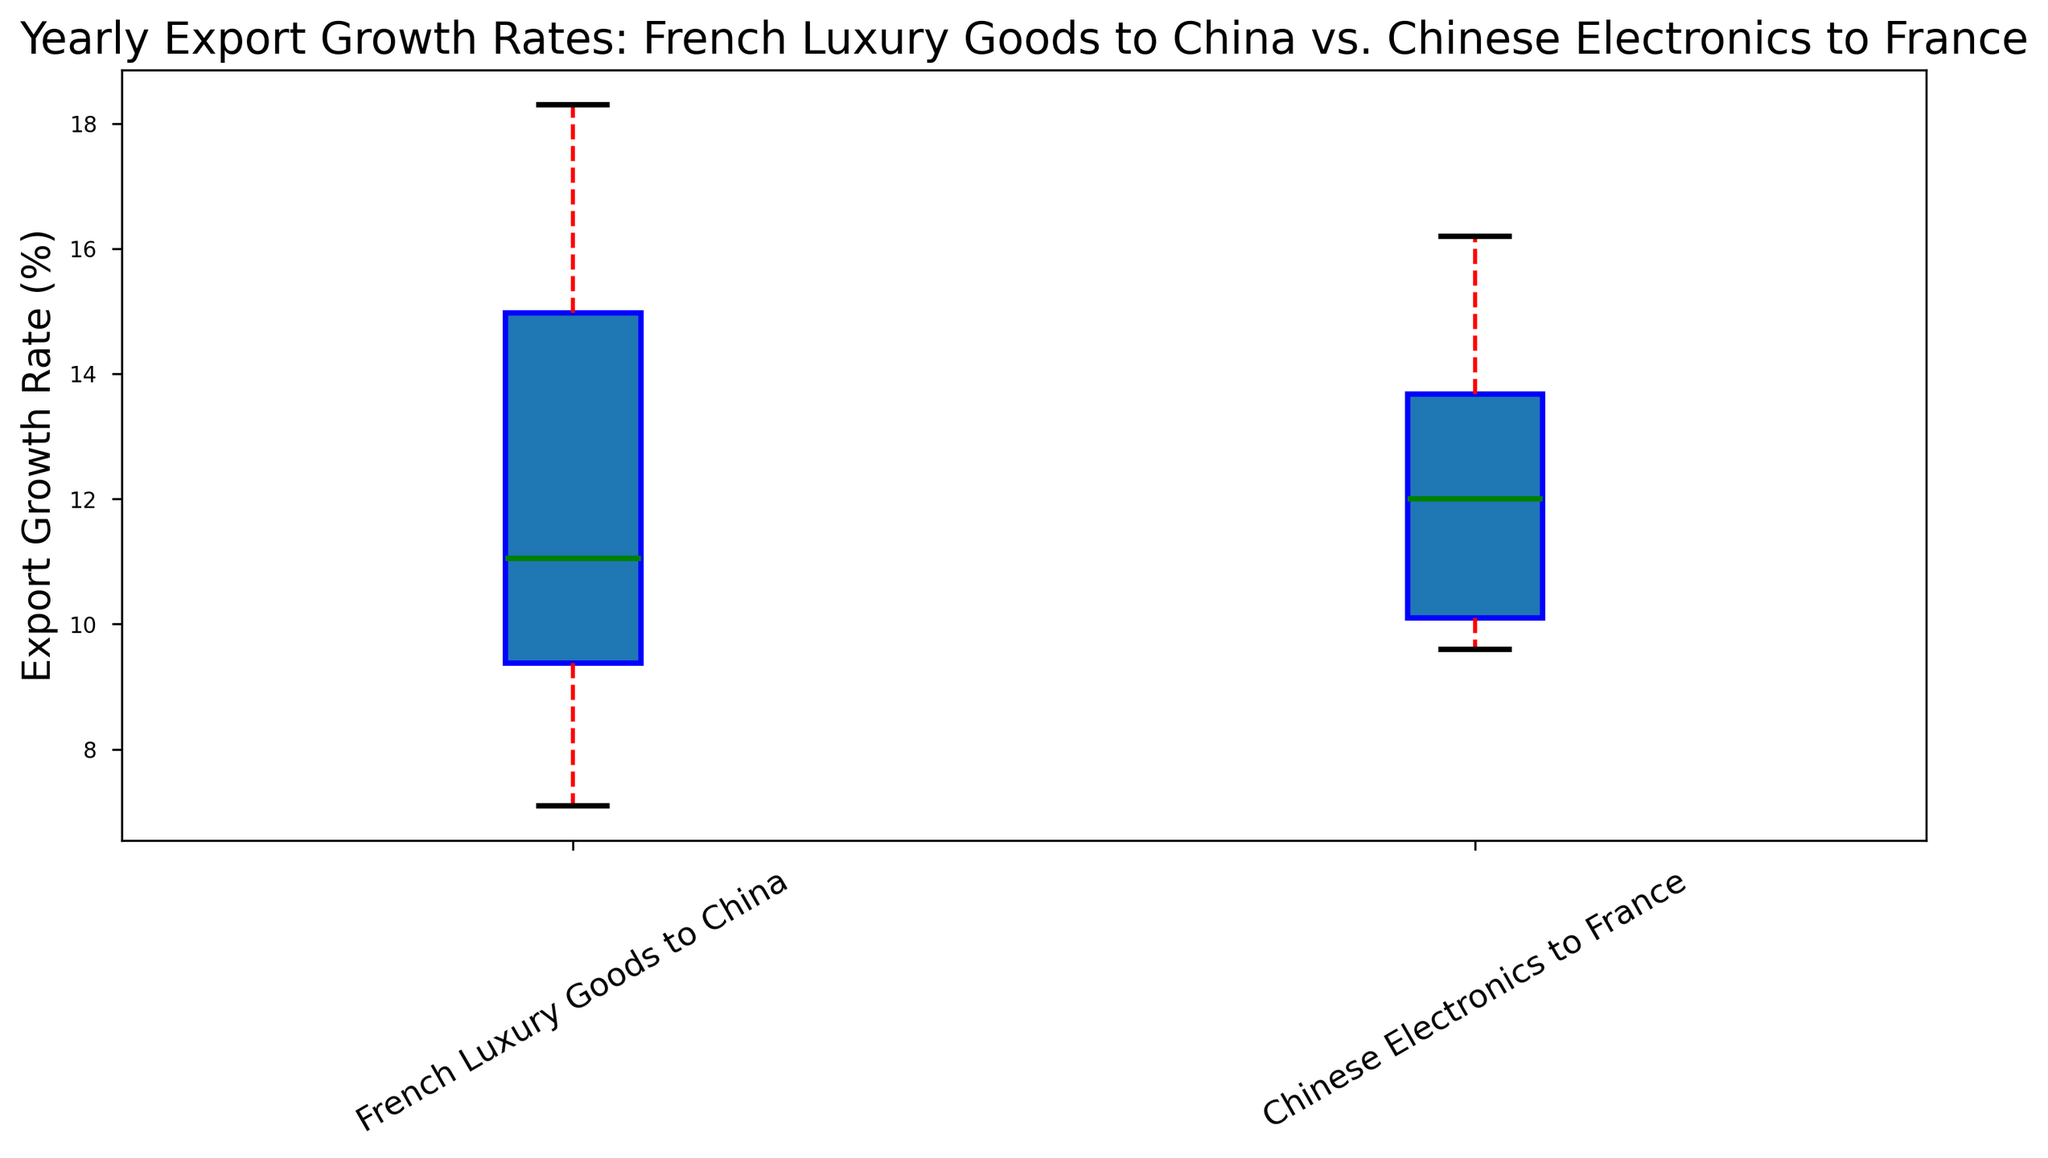What's the median export growth rate for French Luxury Goods to China? To find the median, we need to order the growth rates for French Luxury Goods to China and select the middle value. The rates are: [7.1, 8.4, 9.7, 10.9, 11.2, 14.8, 15.5, 18.3]. There are 8 values, so the median is the average of the 4th and 5th values: (10.9 + 11.2) / 2 = 11.05.
Answer: 11.05 Which category has a higher median export growth rate? We compare the median values of both categories. The median for French Luxury Goods to China is 11.05%, and for Chinese Electronics to France, the median is between the 4th and 5th values of [9.6, 9.8, 10.2, 11.7, 12.3, 13.4, 14.5, 16.2], which is (11.7 + 12.3) / 2 = 12.0%. Thus, Chinese Electronics to France has a higher median.
Answer: Chinese Electronics to France Which category exhibits a higher level of variation in export growth rates? The variation can be observed by looking at the spread of the box plot. A higher level of variation is indicated by a wider interquartile range (IQR) and longer whiskers. Observing the box plots, the French Luxury Goods to China category appears to be more spread out compared to Chinese Electronics to France.
Answer: French Luxury Goods to China What is the interquartile range (IQR) for Chinese Electronics to France? The IQR is the difference between the third quartile (Q3) and the first quartile (Q1). For Chinese Electronics to France, these values can be estimated from the box plot. Let's say Q1 ≈ 9.85 and Q3 ≈ 14.1. Therefore, IQR = 14.1 - 9.85 = 4.25.
Answer: 4.25 Are there any outliers in the export growth rates for French Luxury Goods to China? Outliers are typically shown as individual points outside the whiskers on a box plot. Observing the plot, no individual points are displayed outside the whiskers for French Luxury Goods to China, hence there are no outliers.
Answer: No By how much did the maximum export growth rate differ between the two categories? The maximum (upper whisker limit) for French Luxury Goods to China is around 18.3%, and for Chinese Electronics to France, it is approximately 16.2%. The difference is 18.3 - 16.2 = 2.1%.
Answer: 2.1% Which category has a higher upper quartile value? The upper quartile (Q3) is the top of the box in a box plot. Observing the plot, the upper quartile for French Luxury Goods to China is around 15.5%, and for Chinese Electronics to France, it is around 14.1%. Hence, French Luxury Goods to China has a higher Q3.
Answer: French Luxury Goods to China Which category had a more consistent export growth rate? Consistency can be gauged by the smaller spread of the box plot, indicating less variation. The box for Chinese Electronics to France is less spread compared to French Luxury Goods to China, indicating that Chinese Electronics to France had more consistent growth rates.
Answer: Chinese Electronics to France 